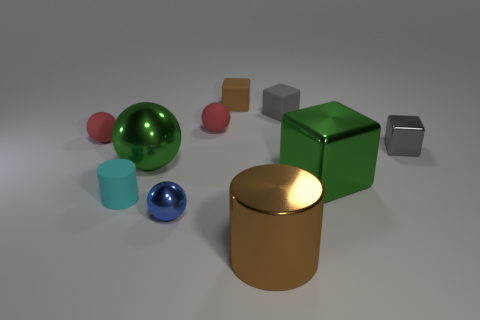There is a matte cube that is on the left side of the big brown object; is it the same size as the gray object that is behind the gray shiny cube?
Keep it short and to the point. Yes. Is the number of small gray rubber cubes greater than the number of red matte objects?
Provide a short and direct response. No. How many small brown cubes are the same material as the tiny cyan cylinder?
Your response must be concise. 1. Is the shape of the cyan thing the same as the tiny brown rubber thing?
Provide a short and direct response. No. There is a green metal object that is to the right of the tiny blue object that is to the left of the brown cylinder to the left of the large green block; what is its size?
Keep it short and to the point. Large. There is a shiny thing that is in front of the small blue ball; are there any red objects that are right of it?
Your answer should be compact. No. There is a green shiny object in front of the shiny sphere that is behind the tiny blue object; what number of metal objects are to the right of it?
Keep it short and to the point. 1. What color is the metallic thing that is both to the right of the large green sphere and on the left side of the big brown metal cylinder?
Make the answer very short. Blue. What number of other large shiny cylinders are the same color as the large cylinder?
Give a very brief answer. 0. How many cubes are either tiny blue things or red things?
Your answer should be very brief. 0. 